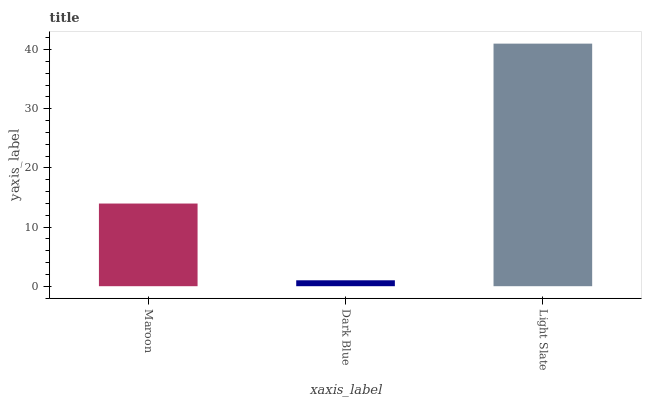Is Dark Blue the minimum?
Answer yes or no. Yes. Is Light Slate the maximum?
Answer yes or no. Yes. Is Light Slate the minimum?
Answer yes or no. No. Is Dark Blue the maximum?
Answer yes or no. No. Is Light Slate greater than Dark Blue?
Answer yes or no. Yes. Is Dark Blue less than Light Slate?
Answer yes or no. Yes. Is Dark Blue greater than Light Slate?
Answer yes or no. No. Is Light Slate less than Dark Blue?
Answer yes or no. No. Is Maroon the high median?
Answer yes or no. Yes. Is Maroon the low median?
Answer yes or no. Yes. Is Dark Blue the high median?
Answer yes or no. No. Is Light Slate the low median?
Answer yes or no. No. 